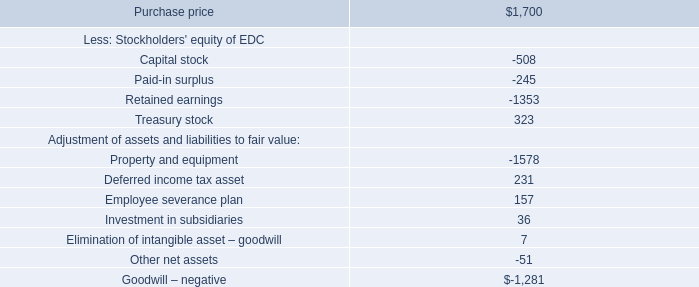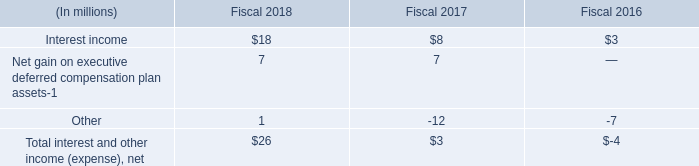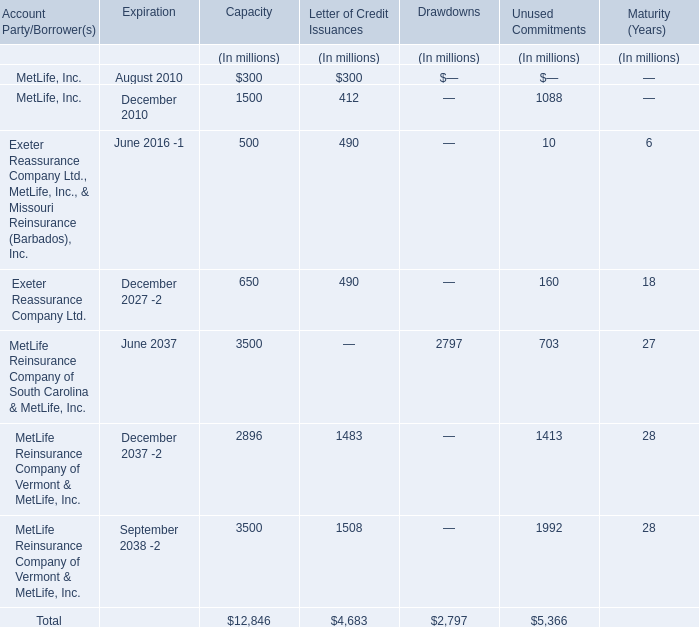What is the sum of MetLife, Inc. in 2010 for capacity? (in million) 
Computations: (300 + 1500)
Answer: 1800.0. 